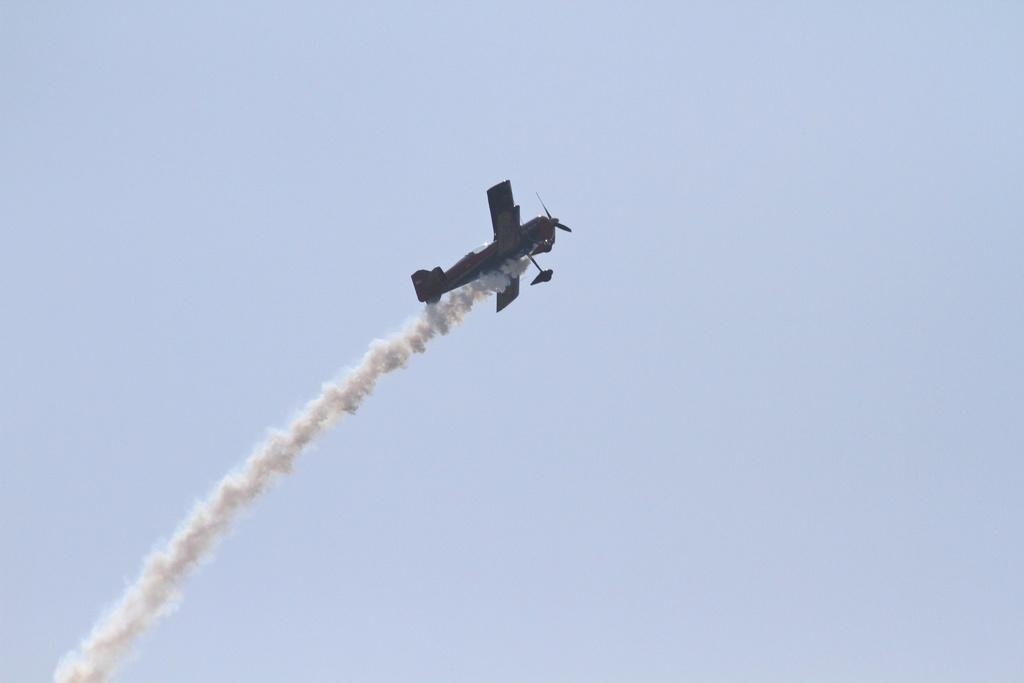What is the main subject of the image? The main subject of the image is an airplane. What is the airplane doing in the image? The airplane is flying in the sky. What can be seen coming from the airplane in the image? There is smoke visible in the image. What is the condition of the sky in the image? The sky is cloudy in the image. Can you tell me how the wren is talking to the airplane in the image? There is no wren present in the image, and therefore no interaction between a wren and the airplane can be observed. 